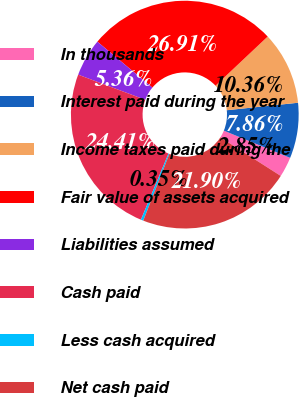<chart> <loc_0><loc_0><loc_500><loc_500><pie_chart><fcel>In thousands<fcel>Interest paid during the year<fcel>Income taxes paid during the<fcel>Fair value of assets acquired<fcel>Liabilities assumed<fcel>Cash paid<fcel>Less cash acquired<fcel>Net cash paid<nl><fcel>2.85%<fcel>7.86%<fcel>10.36%<fcel>26.91%<fcel>5.36%<fcel>24.41%<fcel>0.35%<fcel>21.9%<nl></chart> 